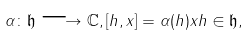Convert formula to latex. <formula><loc_0><loc_0><loc_500><loc_500>\alpha \colon \mathfrak { h } \longrightarrow \mathbb { C } , [ h , x ] = \alpha ( h ) x h \in \mathfrak { h } ,</formula> 